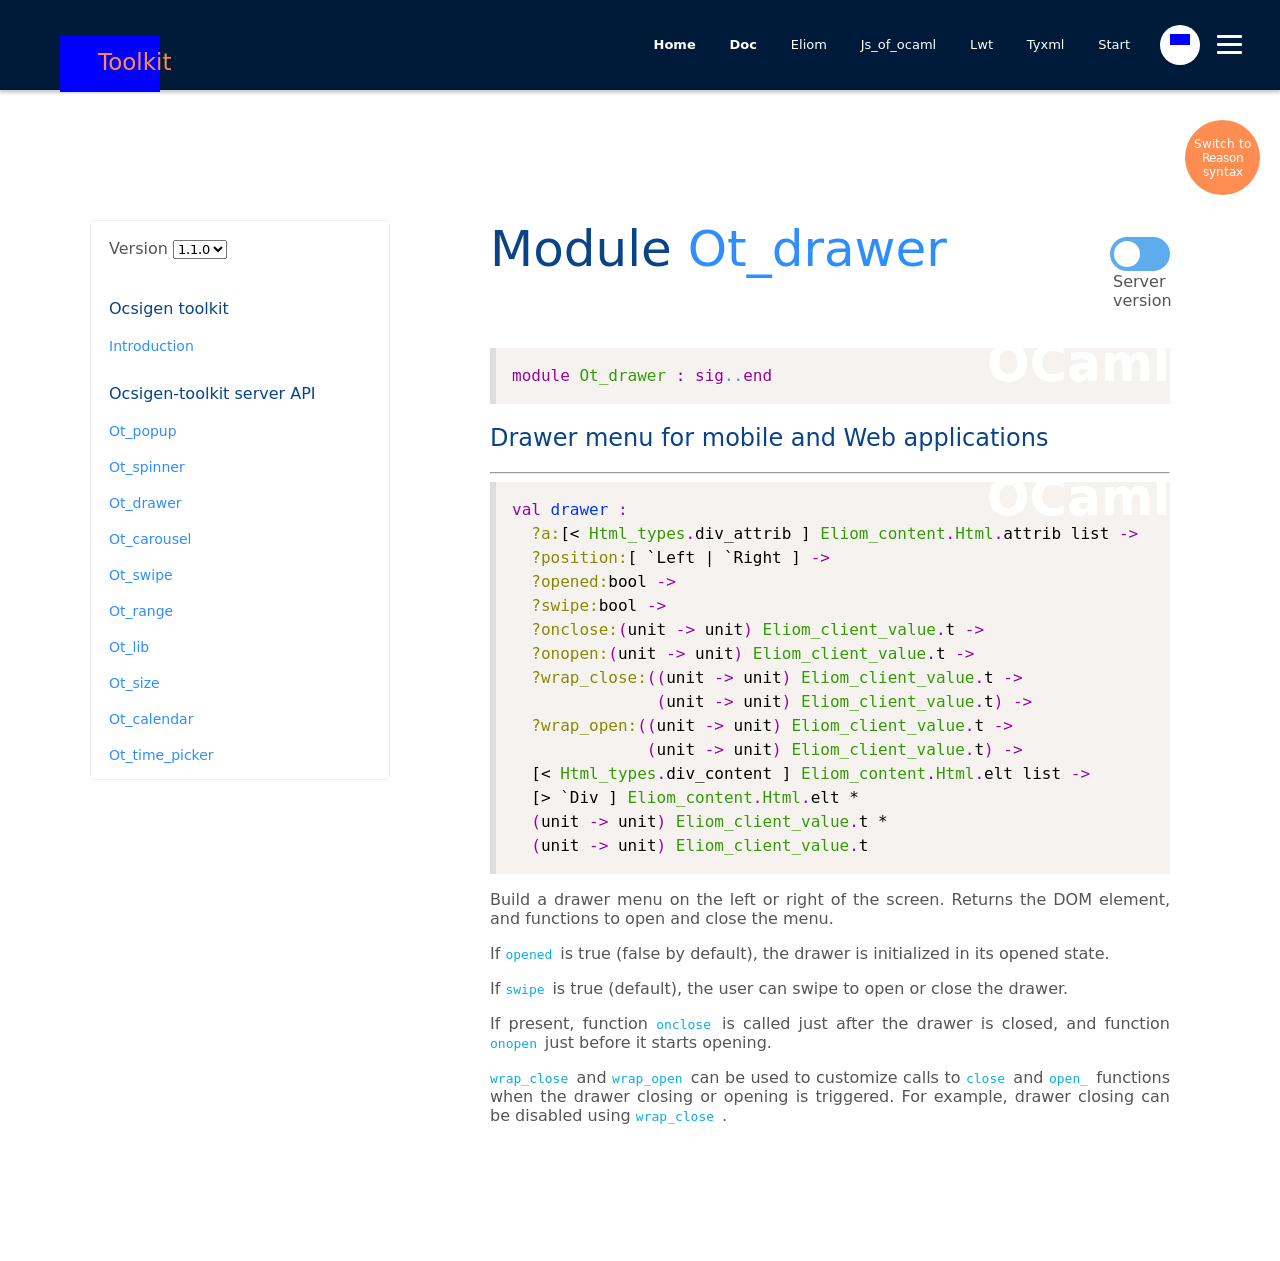How can I start building this website with HTML from the ground up? To start building a website from the ground up using HTML, first define the core structure of your website with basic HTML tags. Begin with a `<!DOCTYPE html>` declaration, followed by adding a `<html>` tag that contains a `<head>` section for metadata and CSS links, and a `<body>` section for the main content. Utilize semantic tags like `<header>`, `<nav>`, `<section>`, `<article>`, `<footer>`, etc., to enhance accessibility and structure of the website. 